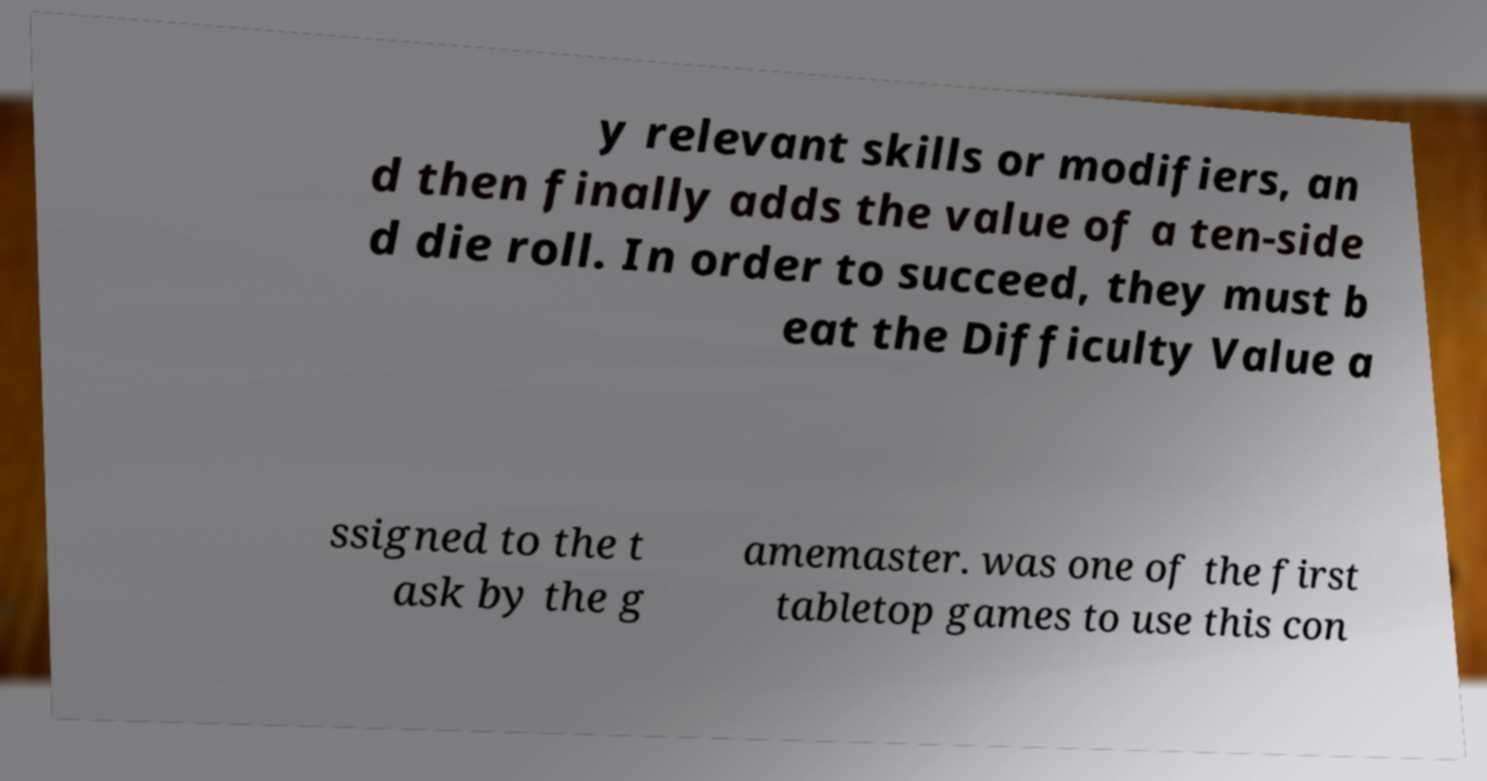Can you read and provide the text displayed in the image?This photo seems to have some interesting text. Can you extract and type it out for me? y relevant skills or modifiers, an d then finally adds the value of a ten-side d die roll. In order to succeed, they must b eat the Difficulty Value a ssigned to the t ask by the g amemaster. was one of the first tabletop games to use this con 